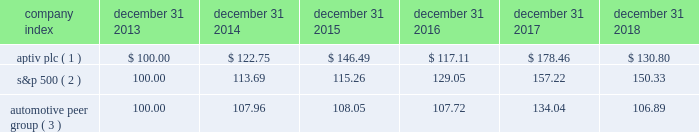Part ii item 5 .
Market for registrant 2019s common equity , related stockholder matters and issuer purchases of equity securities our ordinary shares have been publicly traded since november 17 , 2011 when our ordinary shares were listed and began trading on the new york stock exchange ( 201cnyse 201d ) under the symbol 201cdlph . 201d on december 4 , 2017 , following the spin-off of delphi technologies , the company changed its name to aptiv plc and its nyse symbol to 201captv . 201d as of january 25 , 2019 , there were 2 shareholders of record of our ordinary shares .
The following graph reflects the comparative changes in the value from december 31 , 2013 through december 31 , 2018 , assuming an initial investment of $ 100 and the reinvestment of dividends , if any in ( 1 ) our ordinary shares , ( 2 ) the s&p 500 index and ( 3 ) the automotive peer group .
Historical share prices of our ordinary shares have been adjusted to reflect the separation .
Historical performance may not be indicative of future shareholder returns .
Stock performance graph * $ 100 invested on december 31 , 2013 in our stock or in the relevant index , including reinvestment of dividends .
Fiscal year ended december 31 , 2018 .
( 1 ) aptiv plc , adjusted for the distribution of delphi technologies on december 4 , 2017 ( 2 ) s&p 500 2013 standard & poor 2019s 500 total return index ( 3 ) automotive peer group 2013 adient plc , american axle & manufacturing holdings inc , aptiv plc , borgwarner inc , cooper tire & rubber co , cooper- standard holdings inc , dana inc , dorman products inc , ford motor co , garrett motion inc. , general motors co , gentex corp , gentherm inc , genuine parts co , goodyear tire & rubber co , lear corp , lkq corp , meritor inc , motorcar parts of america inc , standard motor products inc , stoneridge inc , superior industries international inc , tenneco inc , tesla inc , tower international inc , visteon corp , wabco holdings inc company index december 31 , december 31 , december 31 , december 31 , december 31 , december 31 .

What is the difference in percentage performance for aptiv plc versus the automotive peer group for the five year period ending december 31 2018? 
Computations: (((130.80 - 100) / 100) - ((106.89 - 100) / 100))
Answer: 0.2391. 